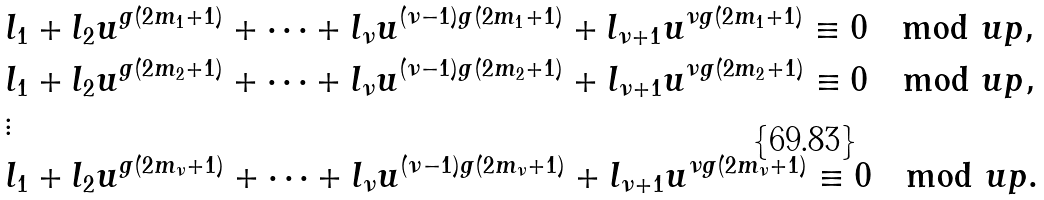<formula> <loc_0><loc_0><loc_500><loc_500>& l _ { 1 } + l _ { 2 } u ^ { g ( 2 m _ { 1 } + 1 ) } + \dots + l _ { \nu } u ^ { ( \nu - 1 ) g ( 2 m _ { 1 } + 1 ) } + l _ { \nu + 1 } u ^ { \nu g ( 2 m _ { 1 } + 1 ) } \equiv 0 \mod u p , \\ & l _ { 1 } + l _ { 2 } u ^ { g ( 2 m _ { 2 } + 1 ) } + \dots + l _ { \nu } u ^ { ( \nu - 1 ) g ( 2 m _ { 2 } + 1 ) } + l _ { \nu + 1 } u ^ { \nu g ( 2 m _ { 2 } + 1 ) } \equiv 0 \mod u p , \\ & \vdots \\ & l _ { 1 } + l _ { 2 } u ^ { g ( 2 m _ { \nu } + 1 ) } + \dots + l _ { \nu } u ^ { ( \nu - 1 ) g ( 2 m _ { \nu } + 1 ) } + l _ { \nu + 1 } u ^ { \nu g ( 2 m _ { \nu } + 1 ) } \equiv 0 \mod u p .</formula> 